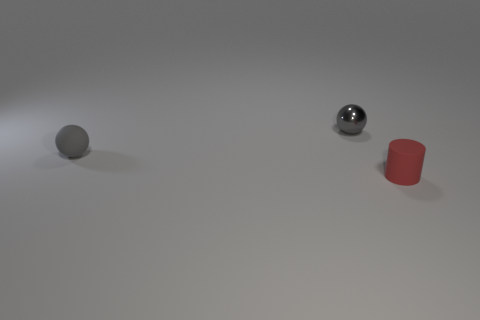Add 3 gray spheres. How many objects exist? 6 Subtract all balls. How many objects are left? 1 Subtract all green metal spheres. Subtract all gray metallic things. How many objects are left? 2 Add 2 tiny rubber cylinders. How many tiny rubber cylinders are left? 3 Add 2 cyan things. How many cyan things exist? 2 Subtract 0 red blocks. How many objects are left? 3 